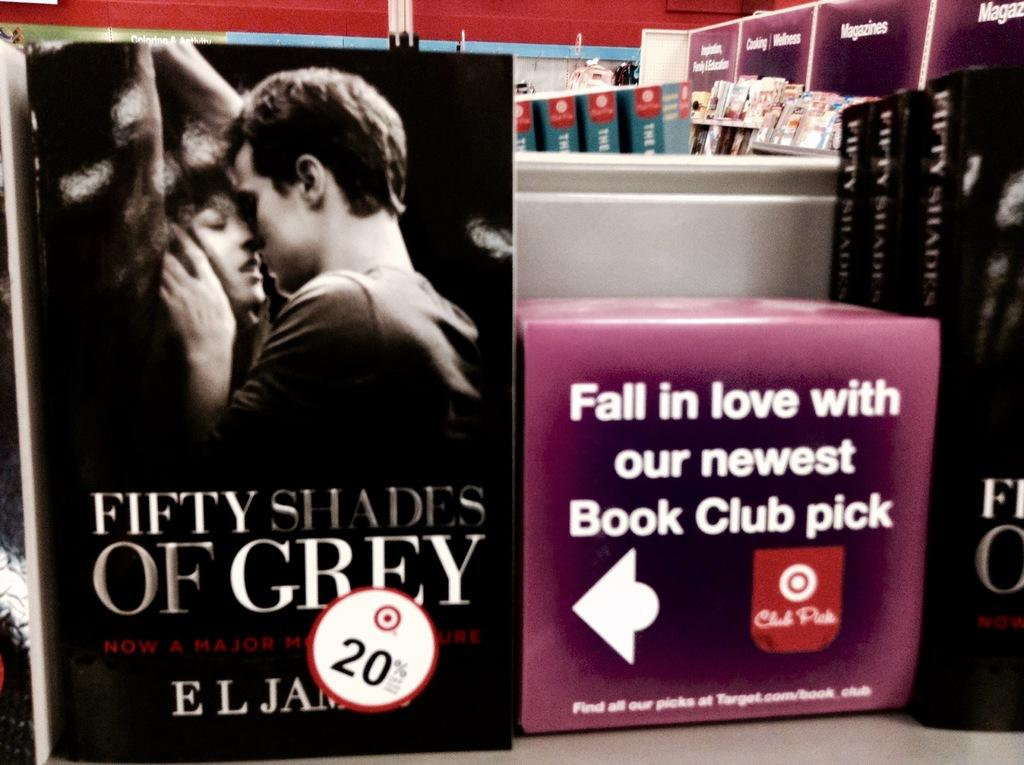<image>
Give a short and clear explanation of the subsequent image. A book called Fifty Shades of Grey with a 20% off sticker. 